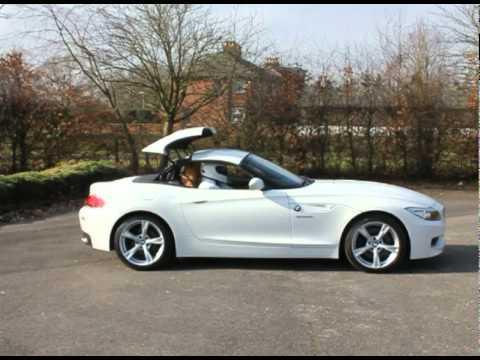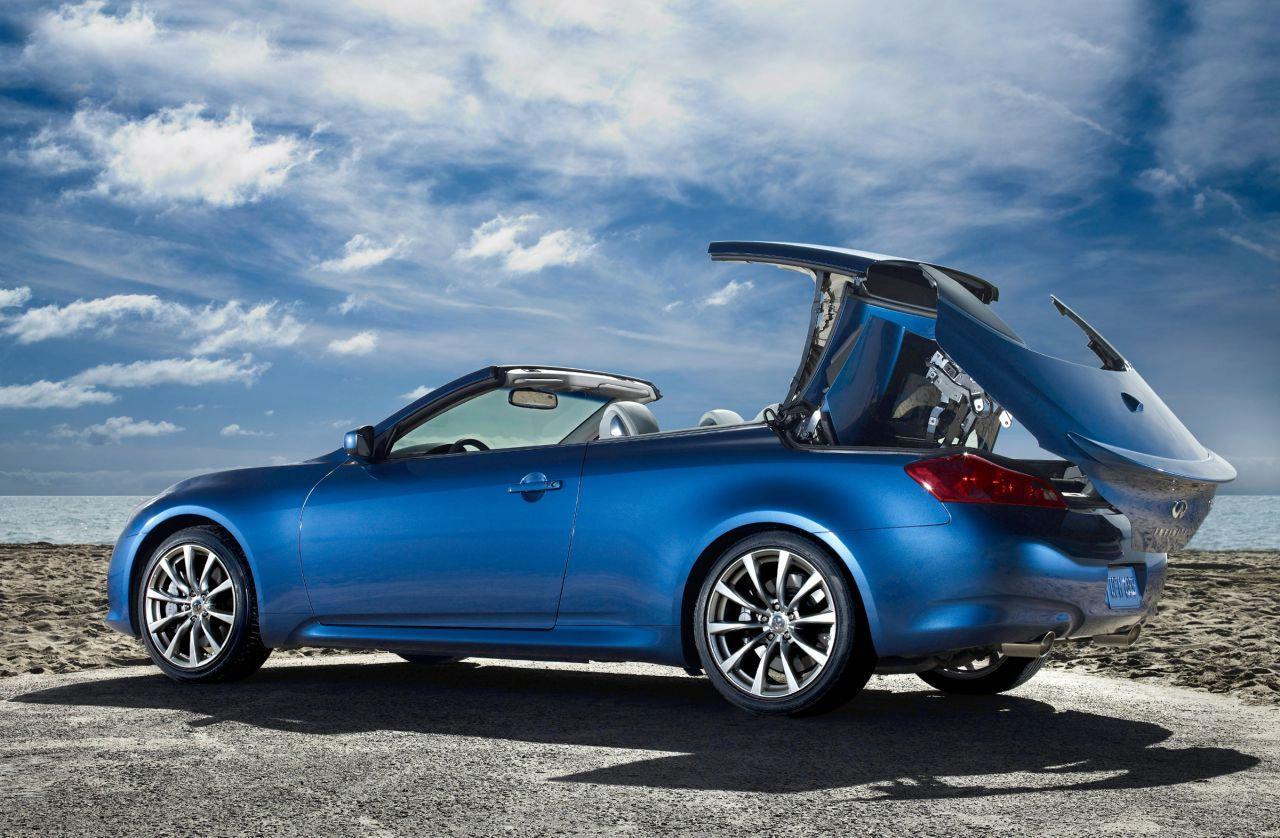The first image is the image on the left, the second image is the image on the right. Given the left and right images, does the statement "In one image, a blue car is shown with its hard roof being lowered into the trunk area." hold true? Answer yes or no. Yes. 